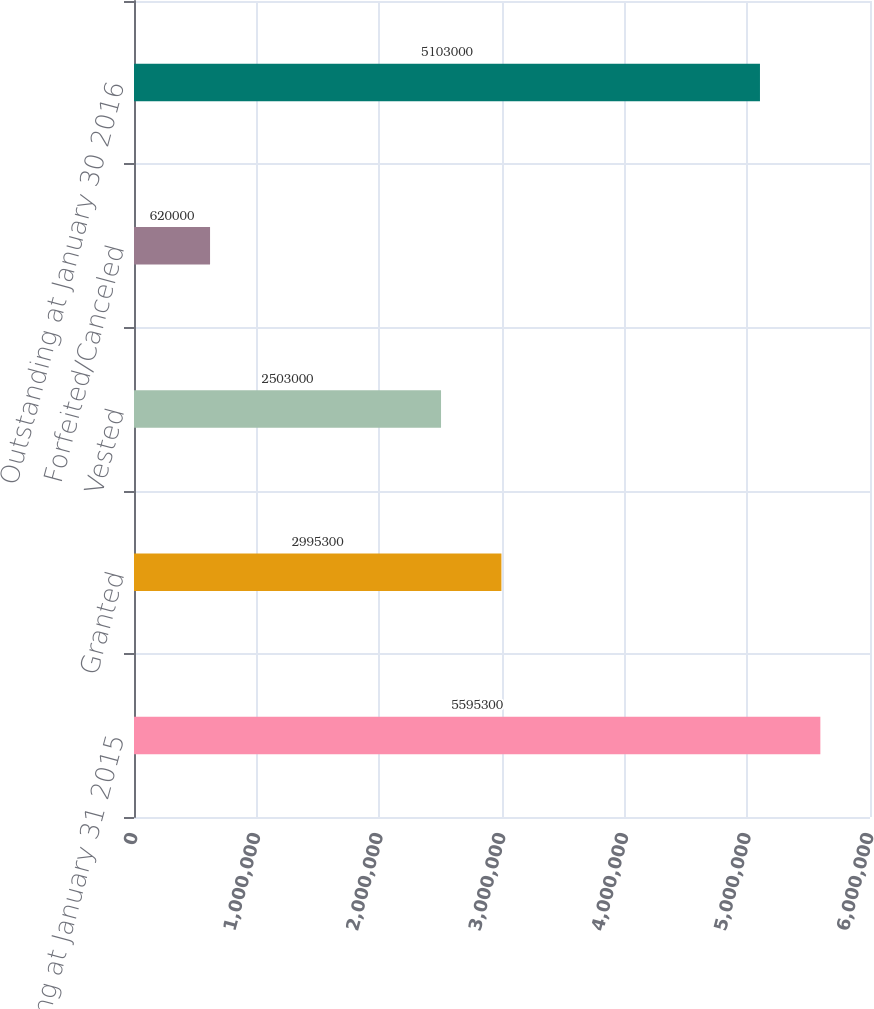Convert chart to OTSL. <chart><loc_0><loc_0><loc_500><loc_500><bar_chart><fcel>Outstanding at January 31 2015<fcel>Granted<fcel>Vested<fcel>Forfeited/Canceled<fcel>Outstanding at January 30 2016<nl><fcel>5.5953e+06<fcel>2.9953e+06<fcel>2.503e+06<fcel>620000<fcel>5.103e+06<nl></chart> 